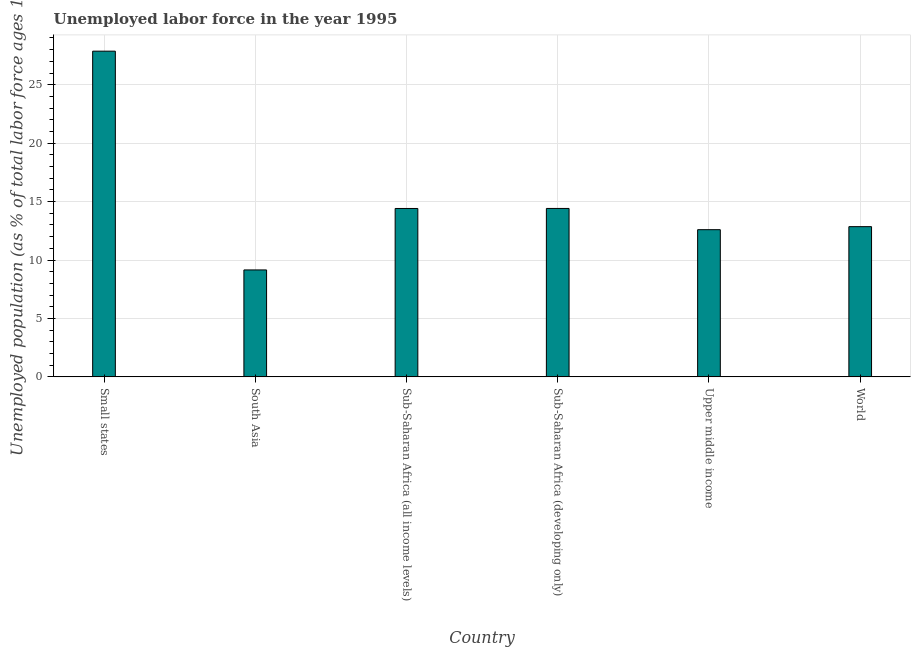Does the graph contain any zero values?
Make the answer very short. No. Does the graph contain grids?
Provide a succinct answer. Yes. What is the title of the graph?
Provide a succinct answer. Unemployed labor force in the year 1995. What is the label or title of the X-axis?
Offer a terse response. Country. What is the label or title of the Y-axis?
Your answer should be compact. Unemployed population (as % of total labor force ages 15-24). What is the total unemployed youth population in South Asia?
Your answer should be very brief. 9.15. Across all countries, what is the maximum total unemployed youth population?
Your answer should be very brief. 27.87. Across all countries, what is the minimum total unemployed youth population?
Keep it short and to the point. 9.15. In which country was the total unemployed youth population maximum?
Keep it short and to the point. Small states. What is the sum of the total unemployed youth population?
Make the answer very short. 91.29. What is the difference between the total unemployed youth population in Small states and Sub-Saharan Africa (all income levels)?
Your answer should be very brief. 13.46. What is the average total unemployed youth population per country?
Keep it short and to the point. 15.21. What is the median total unemployed youth population?
Provide a succinct answer. 13.63. What is the ratio of the total unemployed youth population in Small states to that in Sub-Saharan Africa (developing only)?
Make the answer very short. 1.93. Is the total unemployed youth population in South Asia less than that in World?
Make the answer very short. Yes. Is the difference between the total unemployed youth population in Small states and World greater than the difference between any two countries?
Ensure brevity in your answer.  No. What is the difference between the highest and the second highest total unemployed youth population?
Give a very brief answer. 13.46. What is the difference between the highest and the lowest total unemployed youth population?
Your response must be concise. 18.72. In how many countries, is the total unemployed youth population greater than the average total unemployed youth population taken over all countries?
Ensure brevity in your answer.  1. How many bars are there?
Ensure brevity in your answer.  6. Are all the bars in the graph horizontal?
Ensure brevity in your answer.  No. How many countries are there in the graph?
Provide a short and direct response. 6. What is the Unemployed population (as % of total labor force ages 15-24) of Small states?
Provide a short and direct response. 27.87. What is the Unemployed population (as % of total labor force ages 15-24) in South Asia?
Make the answer very short. 9.15. What is the Unemployed population (as % of total labor force ages 15-24) of Sub-Saharan Africa (all income levels)?
Your response must be concise. 14.41. What is the Unemployed population (as % of total labor force ages 15-24) of Sub-Saharan Africa (developing only)?
Provide a short and direct response. 14.41. What is the Unemployed population (as % of total labor force ages 15-24) in Upper middle income?
Make the answer very short. 12.59. What is the Unemployed population (as % of total labor force ages 15-24) of World?
Your answer should be compact. 12.85. What is the difference between the Unemployed population (as % of total labor force ages 15-24) in Small states and South Asia?
Ensure brevity in your answer.  18.72. What is the difference between the Unemployed population (as % of total labor force ages 15-24) in Small states and Sub-Saharan Africa (all income levels)?
Offer a very short reply. 13.46. What is the difference between the Unemployed population (as % of total labor force ages 15-24) in Small states and Sub-Saharan Africa (developing only)?
Offer a terse response. 13.46. What is the difference between the Unemployed population (as % of total labor force ages 15-24) in Small states and Upper middle income?
Give a very brief answer. 15.27. What is the difference between the Unemployed population (as % of total labor force ages 15-24) in Small states and World?
Your answer should be compact. 15.02. What is the difference between the Unemployed population (as % of total labor force ages 15-24) in South Asia and Sub-Saharan Africa (all income levels)?
Provide a succinct answer. -5.26. What is the difference between the Unemployed population (as % of total labor force ages 15-24) in South Asia and Sub-Saharan Africa (developing only)?
Your answer should be very brief. -5.26. What is the difference between the Unemployed population (as % of total labor force ages 15-24) in South Asia and Upper middle income?
Offer a very short reply. -3.44. What is the difference between the Unemployed population (as % of total labor force ages 15-24) in South Asia and World?
Offer a very short reply. -3.7. What is the difference between the Unemployed population (as % of total labor force ages 15-24) in Sub-Saharan Africa (all income levels) and Sub-Saharan Africa (developing only)?
Provide a short and direct response. -0. What is the difference between the Unemployed population (as % of total labor force ages 15-24) in Sub-Saharan Africa (all income levels) and Upper middle income?
Offer a very short reply. 1.81. What is the difference between the Unemployed population (as % of total labor force ages 15-24) in Sub-Saharan Africa (all income levels) and World?
Offer a very short reply. 1.56. What is the difference between the Unemployed population (as % of total labor force ages 15-24) in Sub-Saharan Africa (developing only) and Upper middle income?
Provide a short and direct response. 1.82. What is the difference between the Unemployed population (as % of total labor force ages 15-24) in Sub-Saharan Africa (developing only) and World?
Keep it short and to the point. 1.56. What is the difference between the Unemployed population (as % of total labor force ages 15-24) in Upper middle income and World?
Make the answer very short. -0.26. What is the ratio of the Unemployed population (as % of total labor force ages 15-24) in Small states to that in South Asia?
Your answer should be very brief. 3.05. What is the ratio of the Unemployed population (as % of total labor force ages 15-24) in Small states to that in Sub-Saharan Africa (all income levels)?
Provide a short and direct response. 1.93. What is the ratio of the Unemployed population (as % of total labor force ages 15-24) in Small states to that in Sub-Saharan Africa (developing only)?
Provide a short and direct response. 1.93. What is the ratio of the Unemployed population (as % of total labor force ages 15-24) in Small states to that in Upper middle income?
Provide a succinct answer. 2.21. What is the ratio of the Unemployed population (as % of total labor force ages 15-24) in Small states to that in World?
Your answer should be compact. 2.17. What is the ratio of the Unemployed population (as % of total labor force ages 15-24) in South Asia to that in Sub-Saharan Africa (all income levels)?
Offer a terse response. 0.64. What is the ratio of the Unemployed population (as % of total labor force ages 15-24) in South Asia to that in Sub-Saharan Africa (developing only)?
Ensure brevity in your answer.  0.64. What is the ratio of the Unemployed population (as % of total labor force ages 15-24) in South Asia to that in Upper middle income?
Provide a short and direct response. 0.73. What is the ratio of the Unemployed population (as % of total labor force ages 15-24) in South Asia to that in World?
Make the answer very short. 0.71. What is the ratio of the Unemployed population (as % of total labor force ages 15-24) in Sub-Saharan Africa (all income levels) to that in Sub-Saharan Africa (developing only)?
Your answer should be very brief. 1. What is the ratio of the Unemployed population (as % of total labor force ages 15-24) in Sub-Saharan Africa (all income levels) to that in Upper middle income?
Offer a very short reply. 1.14. What is the ratio of the Unemployed population (as % of total labor force ages 15-24) in Sub-Saharan Africa (all income levels) to that in World?
Give a very brief answer. 1.12. What is the ratio of the Unemployed population (as % of total labor force ages 15-24) in Sub-Saharan Africa (developing only) to that in Upper middle income?
Ensure brevity in your answer.  1.14. What is the ratio of the Unemployed population (as % of total labor force ages 15-24) in Sub-Saharan Africa (developing only) to that in World?
Your answer should be compact. 1.12. 